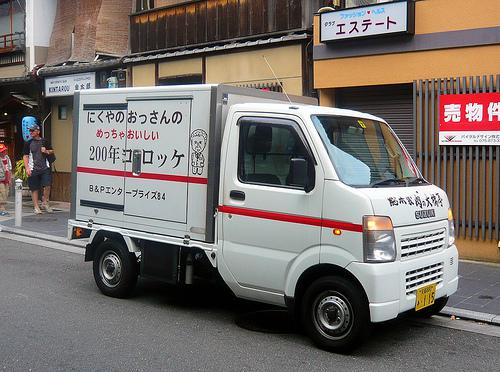Question: where was the picture taken?
Choices:
A. The hill.
B. The school.
C. On the street.
D. The yard.
Answer with the letter. Answer: C Question: what is white?
Choices:
A. The cocaine.
B. The paint.
C. The walls.
D. A truck.
Answer with the letter. Answer: D Question: what is gray?
Choices:
A. The bus.
B. The ground.
C. The scientists coat.
D. The doctor's scalpel.
Answer with the letter. Answer: B Question: when was the picture taken?
Choices:
A. Yesterday.
B. Last week.
C. Daytime.
D. Tuesday.
Answer with the letter. Answer: C Question: who is wearing shorts?
Choices:
A. Woman on bicycle.
B. Man on stoop.
C. Woman in road.
D. Man on the sidewalk.
Answer with the letter. Answer: D Question: what is yellow?
Choices:
A. Yield sign.
B. Billboard.
C. Car on the left.
D. License plate.
Answer with the letter. Answer: D Question: who is wearing a hat?
Choices:
A. The baseball player.
B. The woman on the street.
C. Man on left.
D. The man in the bathroom.
Answer with the letter. Answer: C Question: where are tires?
Choices:
A. At the tire store.
B. On the truck.
C. On my mini van.
D. On the monster truck.
Answer with the letter. Answer: B 